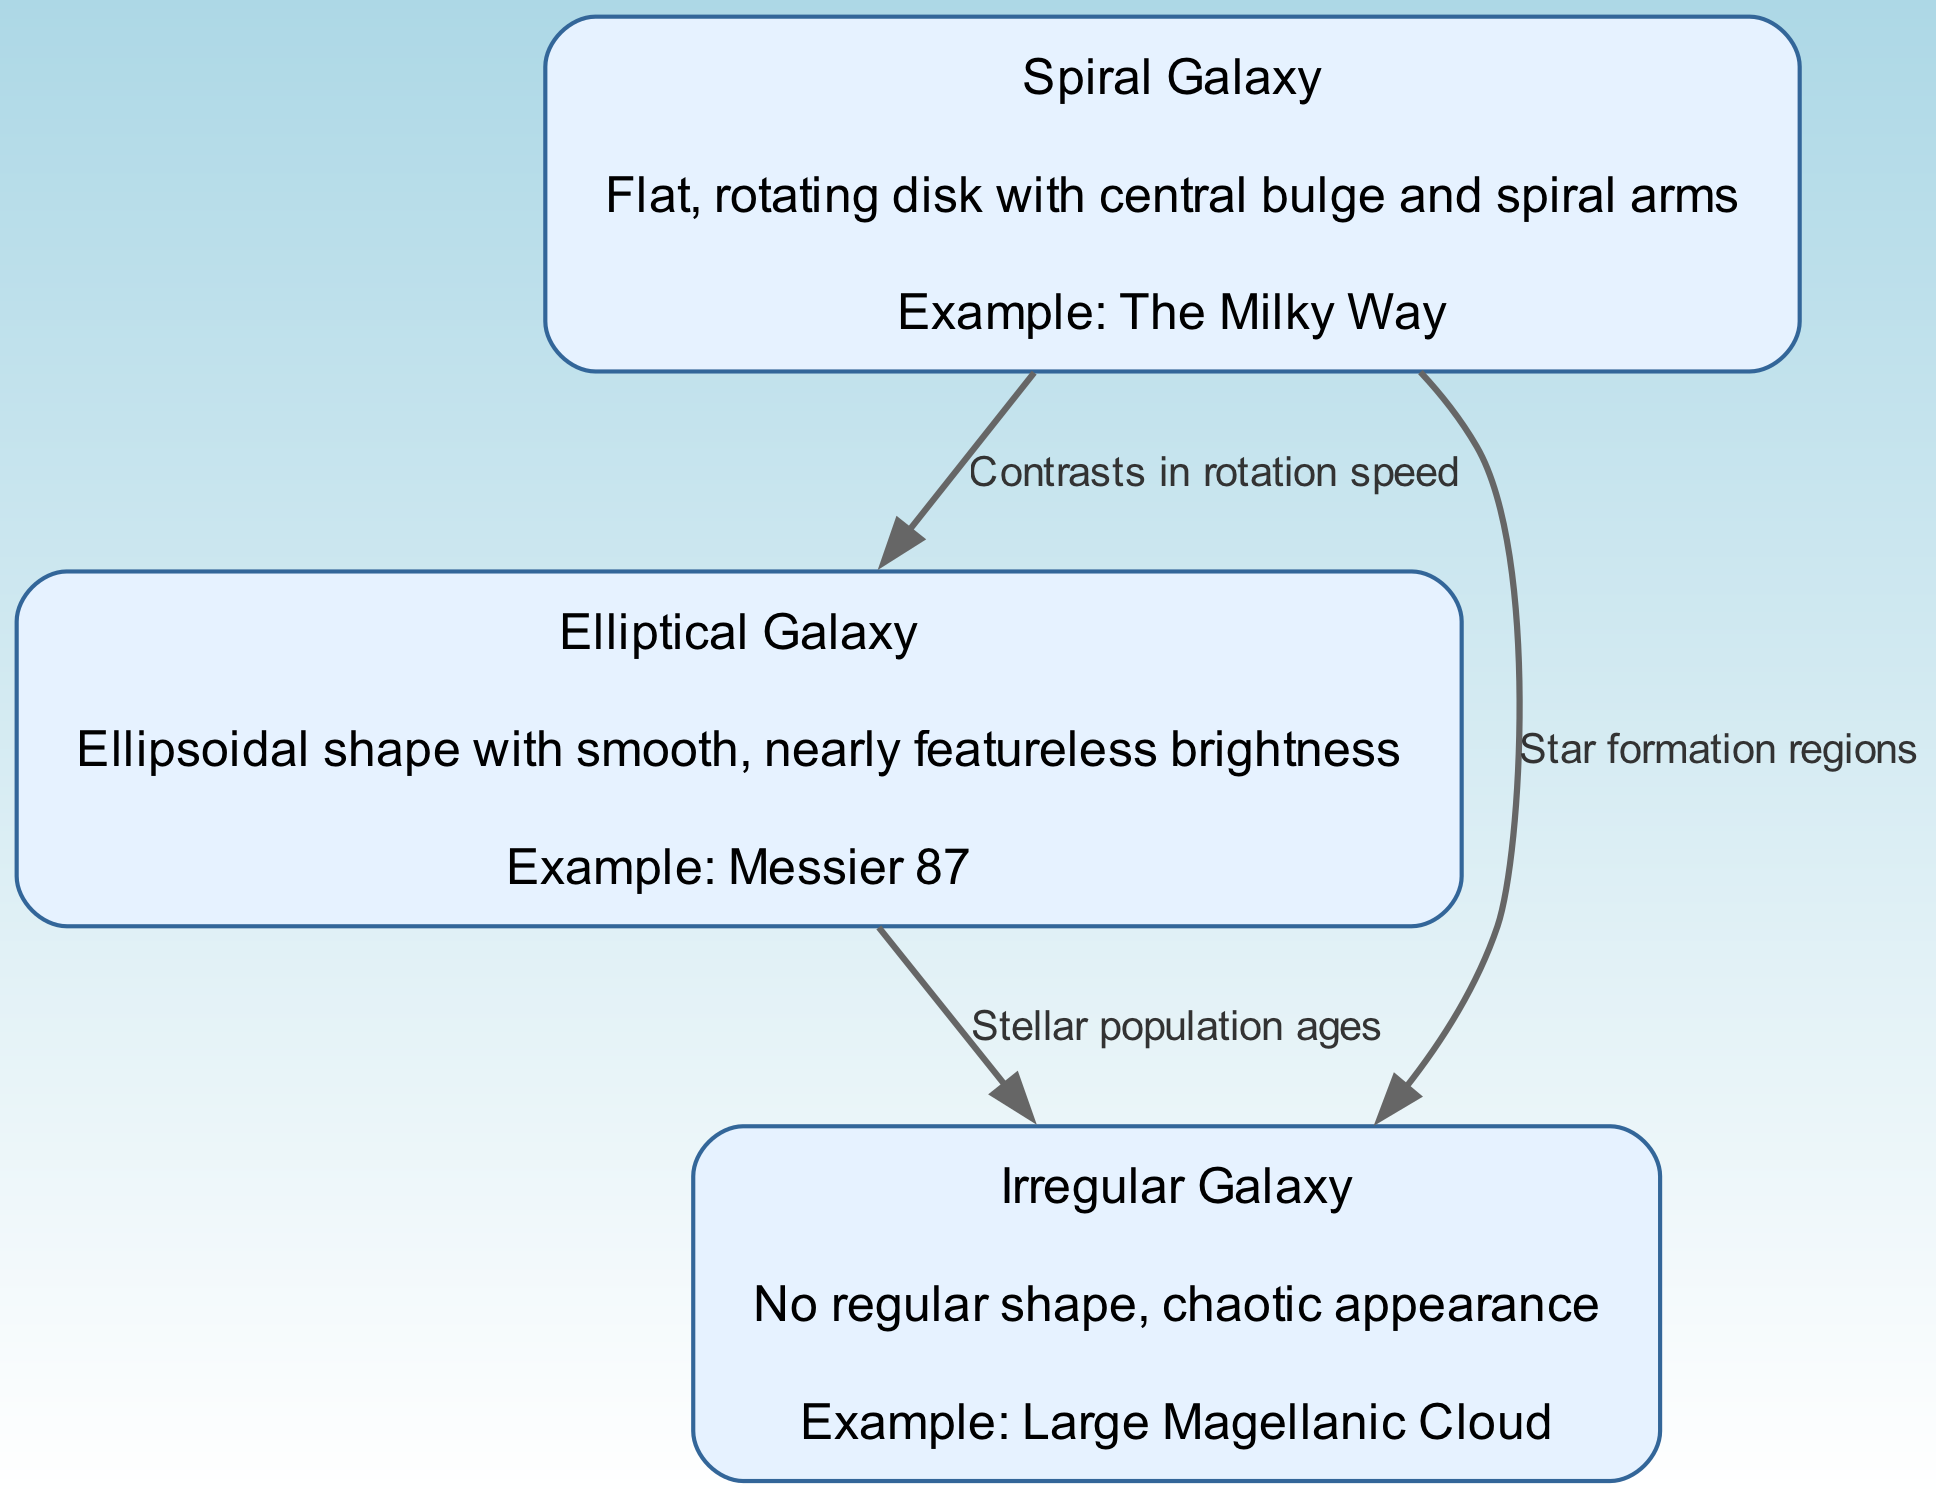What are the three types of galaxies shown in the diagram? The diagram displays three types of galaxies, which can be found in the nodes: Spiral Galaxy, Elliptical Galaxy, and Irregular Galaxy.
Answer: Spiral Galaxy, Elliptical Galaxy, Irregular Galaxy What is the example of the Spiral Galaxy given in the diagram? The diagram states that the Milky Way is an example of a Spiral Galaxy, which is mentioned in the description section of the spiral node.
Answer: The Milky Way How many edges are there in the diagram? The diagram contains three edges, which connect the various galaxy types and indicate their relationships.
Answer: 3 What contrasts are mentioned between Spiral and Elliptical galaxies? The edge connecting Spiral and Elliptical galaxies indicates "Contrasts in rotation speed," which implies a difference in the rotation characteristics of these two types.
Answer: Contrasts in rotation speed What type of galaxy is associated with chaotic appearance? The diagram describes Irregular Galaxies as having "No regular shape, chaotic appearance," thus making it clear that the chaotic nature is attributed to Irregular Galaxies.
Answer: Irregular Galaxy What does the edge between Elliptical and Irregular galaxies represent? The connection indicates "Stellar population ages," meaning that there is a relationship regarding the ages of stars found in these two types of galaxies.
Answer: Stellar population ages Which galaxy type has a central bulge and spiral arms? The description under the Spiral Galaxy node highlights the presence of a central bulge and spiral arms, defining its structure.
Answer: Spiral Galaxy What is a notable feature of the Elliptical Galaxy as described in the diagram? The diagram describes the Elliptical Galaxy as having "Ellipsoidal shape with smooth, nearly featureless brightness," which highlights its visual characteristics.
Answer: Ellipsoidal shape 